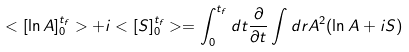Convert formula to latex. <formula><loc_0><loc_0><loc_500><loc_500>< [ \ln A ] ^ { t _ { f } } _ { 0 } > + i < [ S ] ^ { t _ { f } } _ { 0 } > = \int _ { 0 } ^ { t _ { f } } d t \frac { \partial } { \partial t } \int d { r } A ^ { 2 } ( \ln A + i S )</formula> 